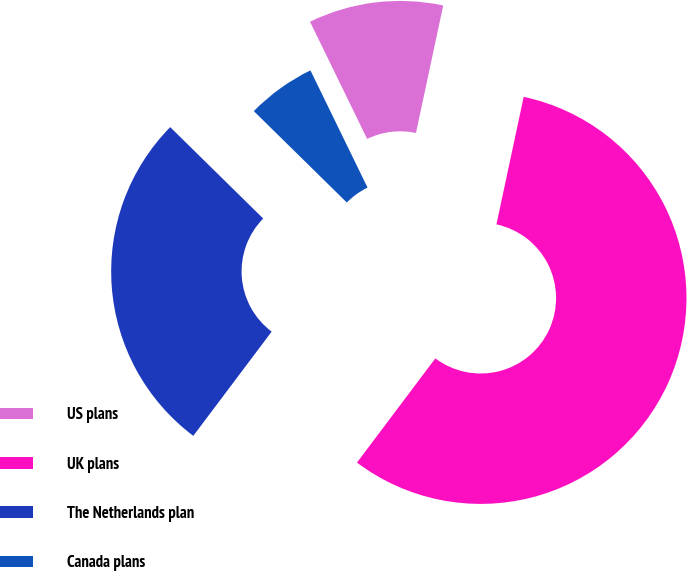<chart> <loc_0><loc_0><loc_500><loc_500><pie_chart><fcel>US plans<fcel>UK plans<fcel>The Netherlands plan<fcel>Canada plans<nl><fcel>10.57%<fcel>56.91%<fcel>27.1%<fcel>5.42%<nl></chart> 